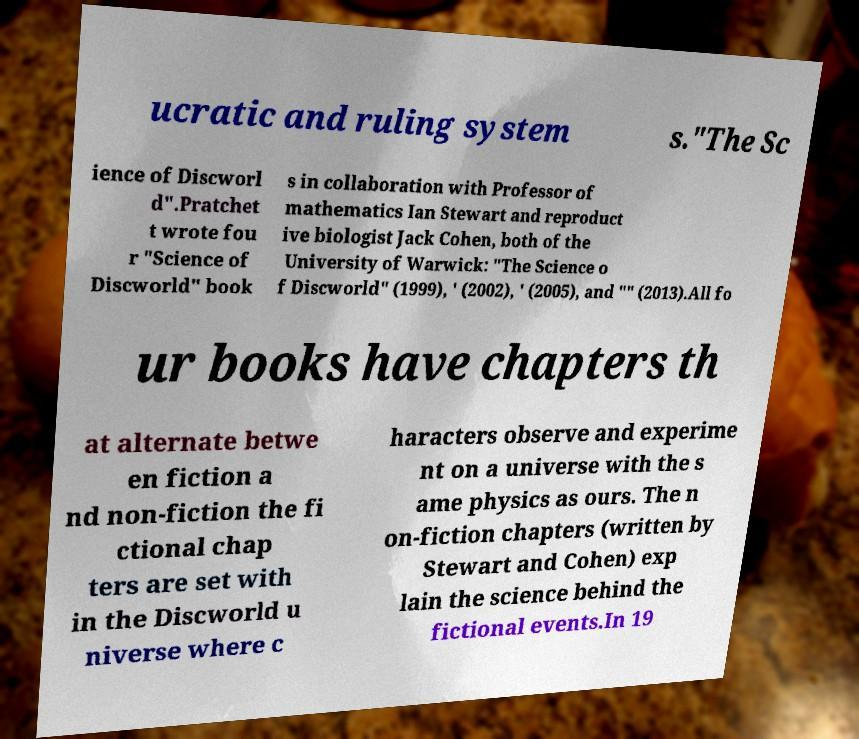For documentation purposes, I need the text within this image transcribed. Could you provide that? ucratic and ruling system s."The Sc ience of Discworl d".Pratchet t wrote fou r "Science of Discworld" book s in collaboration with Professor of mathematics Ian Stewart and reproduct ive biologist Jack Cohen, both of the University of Warwick: "The Science o f Discworld" (1999), ' (2002), ' (2005), and "" (2013).All fo ur books have chapters th at alternate betwe en fiction a nd non-fiction the fi ctional chap ters are set with in the Discworld u niverse where c haracters observe and experime nt on a universe with the s ame physics as ours. The n on-fiction chapters (written by Stewart and Cohen) exp lain the science behind the fictional events.In 19 